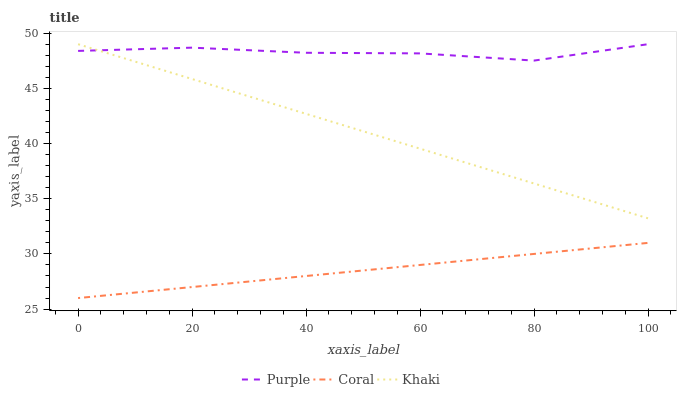Does Coral have the minimum area under the curve?
Answer yes or no. Yes. Does Purple have the maximum area under the curve?
Answer yes or no. Yes. Does Khaki have the minimum area under the curve?
Answer yes or no. No. Does Khaki have the maximum area under the curve?
Answer yes or no. No. Is Khaki the smoothest?
Answer yes or no. Yes. Is Purple the roughest?
Answer yes or no. Yes. Is Coral the smoothest?
Answer yes or no. No. Is Coral the roughest?
Answer yes or no. No. Does Coral have the lowest value?
Answer yes or no. Yes. Does Khaki have the lowest value?
Answer yes or no. No. Does Khaki have the highest value?
Answer yes or no. Yes. Does Coral have the highest value?
Answer yes or no. No. Is Coral less than Khaki?
Answer yes or no. Yes. Is Purple greater than Coral?
Answer yes or no. Yes. Does Khaki intersect Purple?
Answer yes or no. Yes. Is Khaki less than Purple?
Answer yes or no. No. Is Khaki greater than Purple?
Answer yes or no. No. Does Coral intersect Khaki?
Answer yes or no. No. 